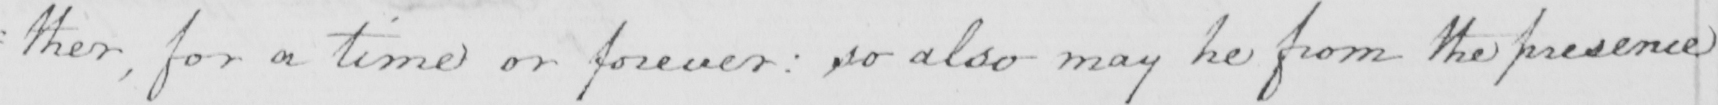Please transcribe the handwritten text in this image. : ther , for a time or forever :  so also may he from the presence 